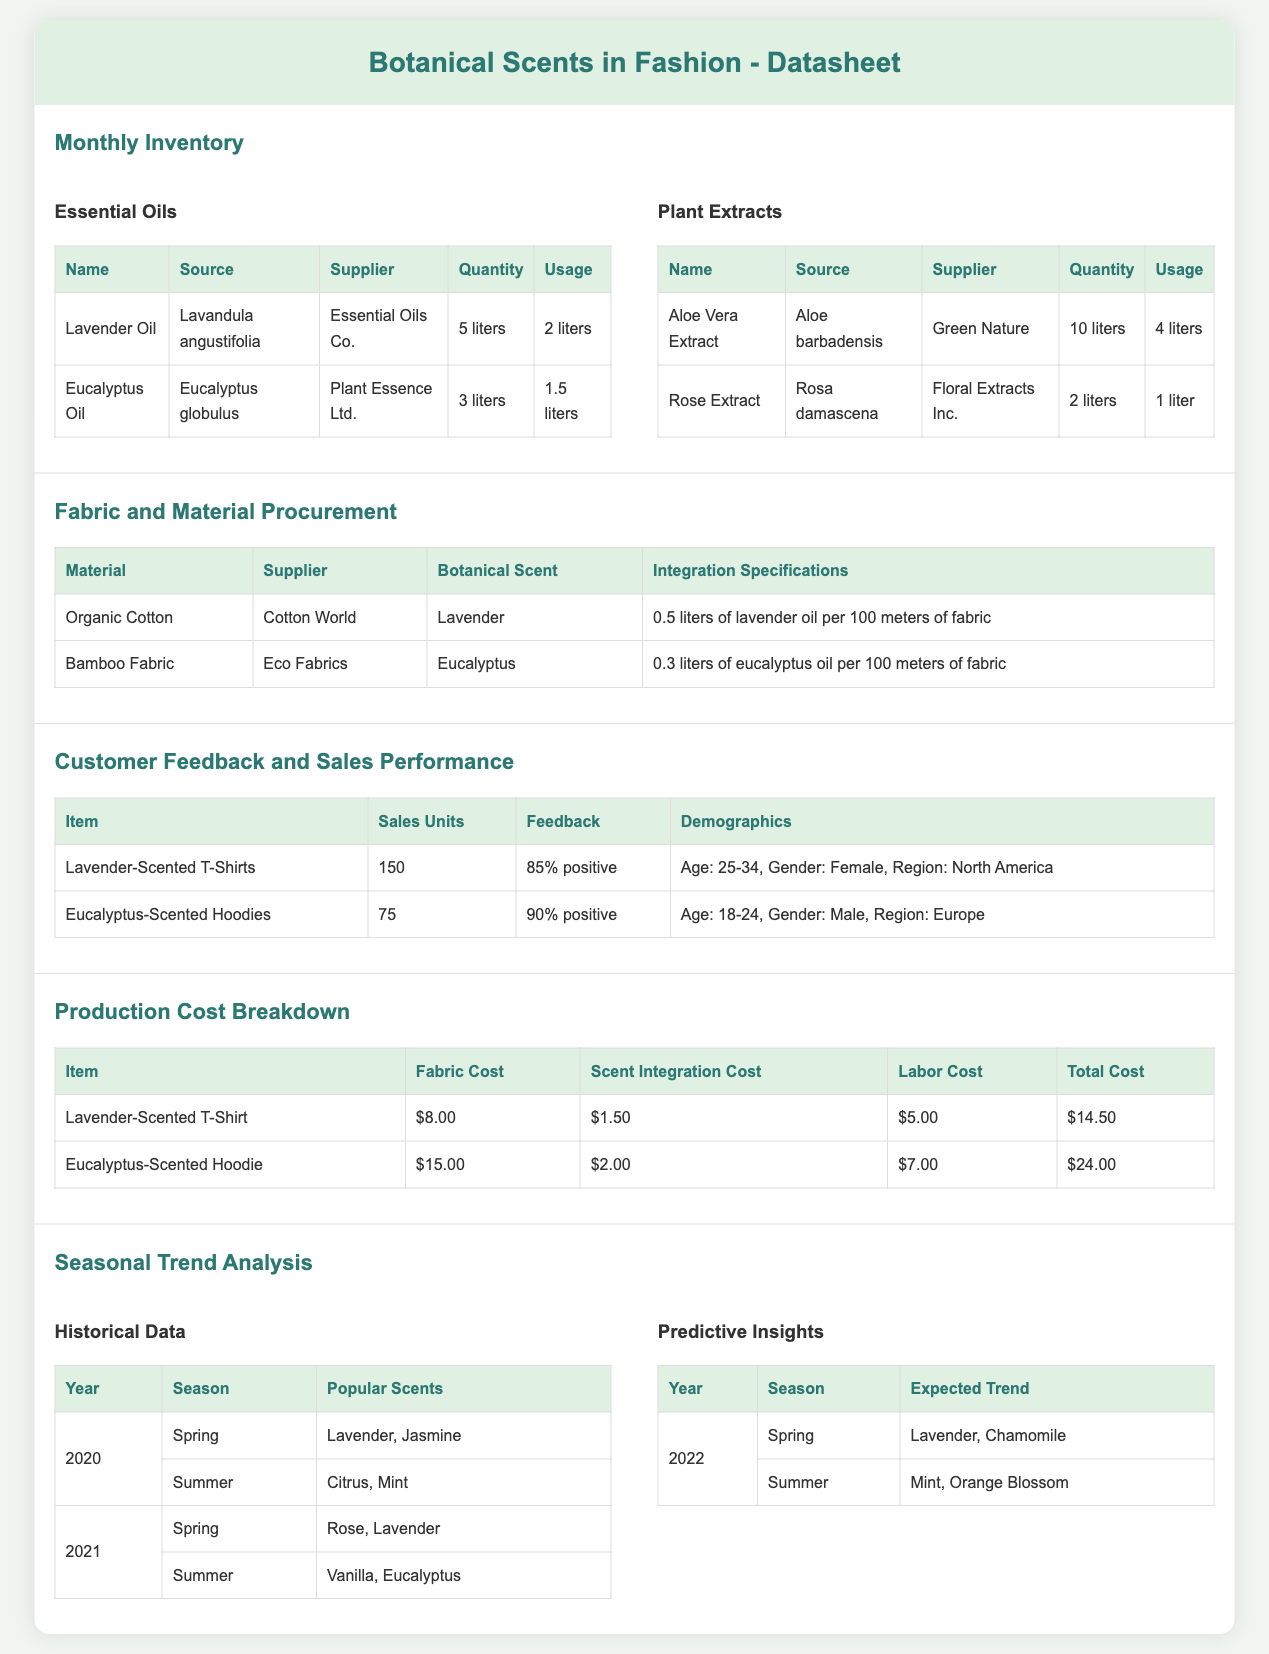What is the quantity of Lavender Oil? The document indicates a quantity of 5 liters for Lavender Oil.
Answer: 5 liters Who is the supplier of Eucalyptus Oil? The supplier for Eucalyptus Oil listed in the document is Plant Essence Ltd.
Answer: Plant Essence Ltd What is the feedback percentage for Eucalyptus-Scented Hoodies? The document states that the feedback for Eucalyptus-Scented Hoodies is 90% positive.
Answer: 90% positive What is the total cost of a Lavender-Scented T-Shirt? The total cost is calculated by summing the fabric, scent integration, and labor costs, which total $14.50.
Answer: $14.50 Which material requires 0.5 liters of oil per 100 meters? According to the document, Organic Cotton requires 0.5 liters of lavender oil per 100 meters.
Answer: Organic Cotton What were the popular scents in Spring 2021? The document lists Rose and Lavender as the popular scents for Spring 2021.
Answer: Rose, Lavender What is the expected trend for Summer 2022? The predictive insights indicate that the expected trend for Summer 2022 is Mint and Orange Blossom.
Answer: Mint, Orange Blossom How many units of Lavender-Scented T-Shirts were sold? The document specifies that 150 units of Lavender-Scented T-Shirts were sold.
Answer: 150 